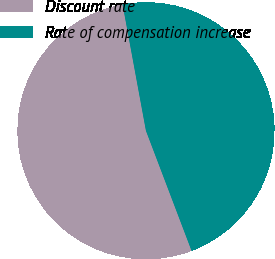<chart> <loc_0><loc_0><loc_500><loc_500><pie_chart><fcel>Discount rate<fcel>Rate of compensation increase<nl><fcel>52.87%<fcel>47.13%<nl></chart> 